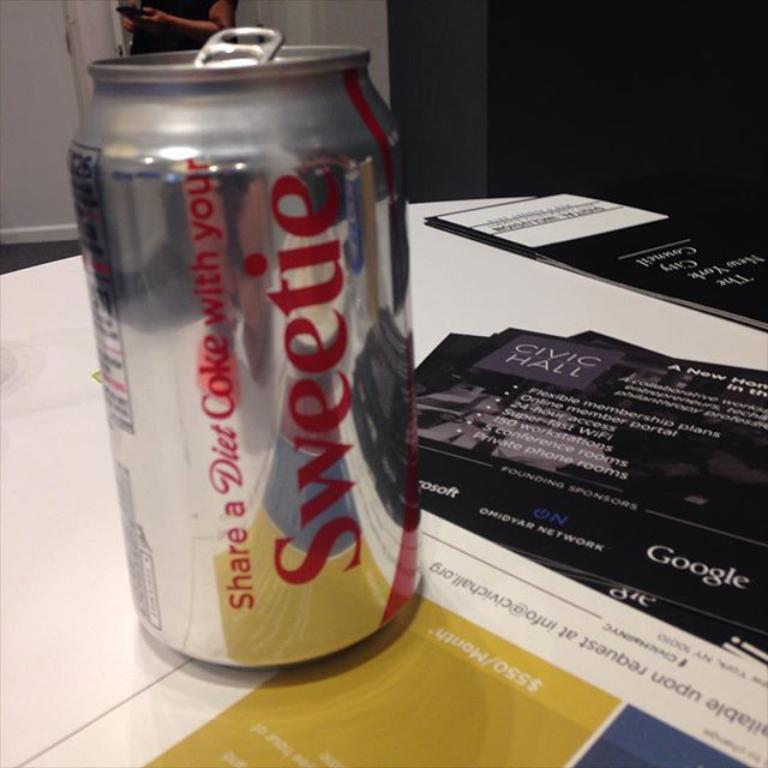<image>
Present a compact description of the photo's key features. A Coke can says Sweetie on the side of it. 